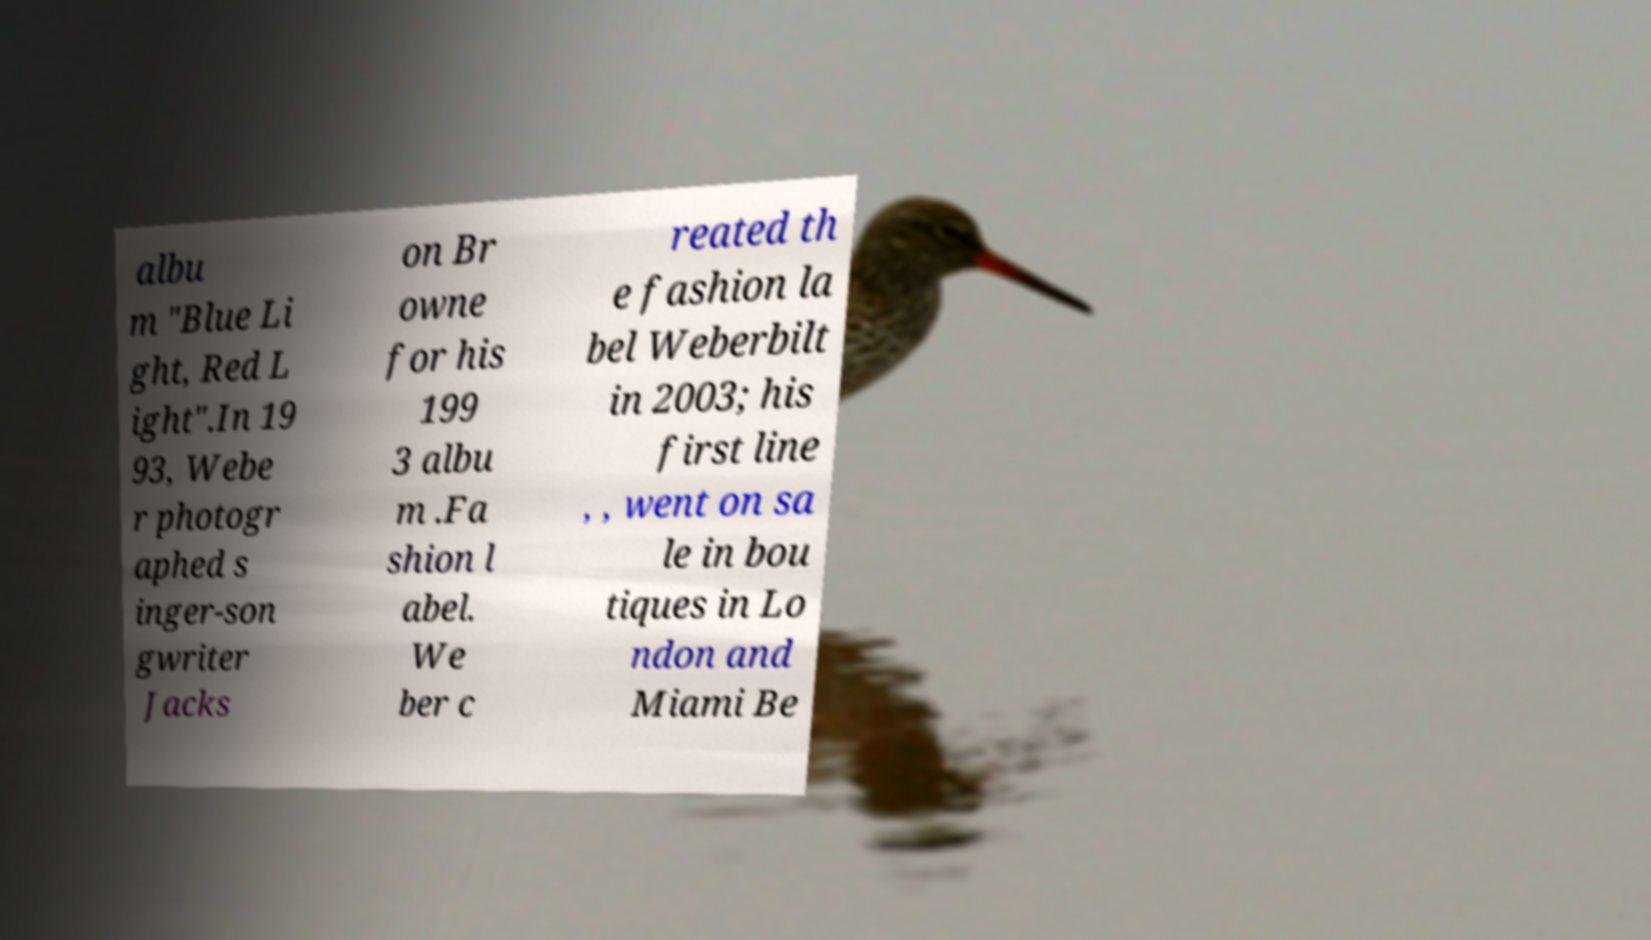Can you read and provide the text displayed in the image?This photo seems to have some interesting text. Can you extract and type it out for me? albu m "Blue Li ght, Red L ight".In 19 93, Webe r photogr aphed s inger-son gwriter Jacks on Br owne for his 199 3 albu m .Fa shion l abel. We ber c reated th e fashion la bel Weberbilt in 2003; his first line , , went on sa le in bou tiques in Lo ndon and Miami Be 